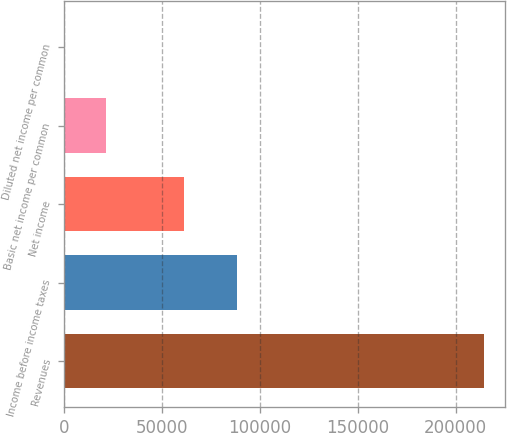Convert chart. <chart><loc_0><loc_0><loc_500><loc_500><bar_chart><fcel>Revenues<fcel>Income before income taxes<fcel>Net income<fcel>Basic net income per common<fcel>Diluted net income per common<nl><fcel>214683<fcel>88361<fcel>61210<fcel>21469.8<fcel>1.62<nl></chart> 